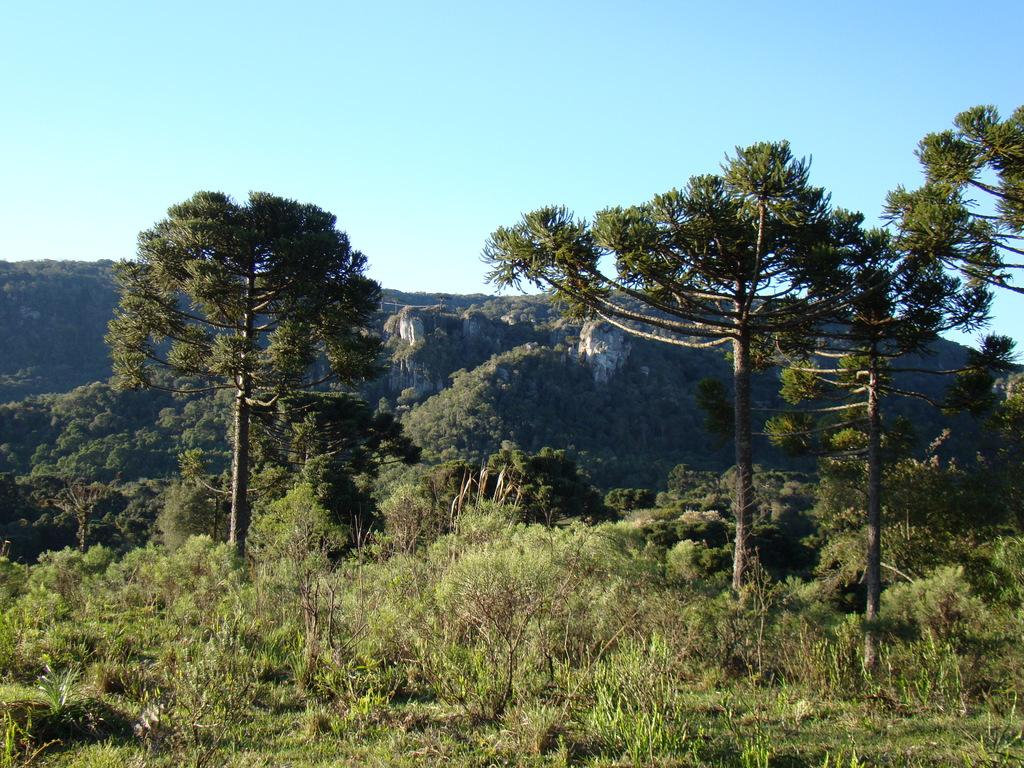What type of surface is visible in the image? There is grass on the surface in the image. What type of vegetation can be seen in the image? There are trees visible in the image. What geographical feature is present in the image? There are mountains in the image. What is visible above the surface in the image? The sky is visible in the image. What type of cord is hanging from the trees in the image? There is no cord hanging from the trees in the image; only trees, grass, mountains, and the sky are present. 